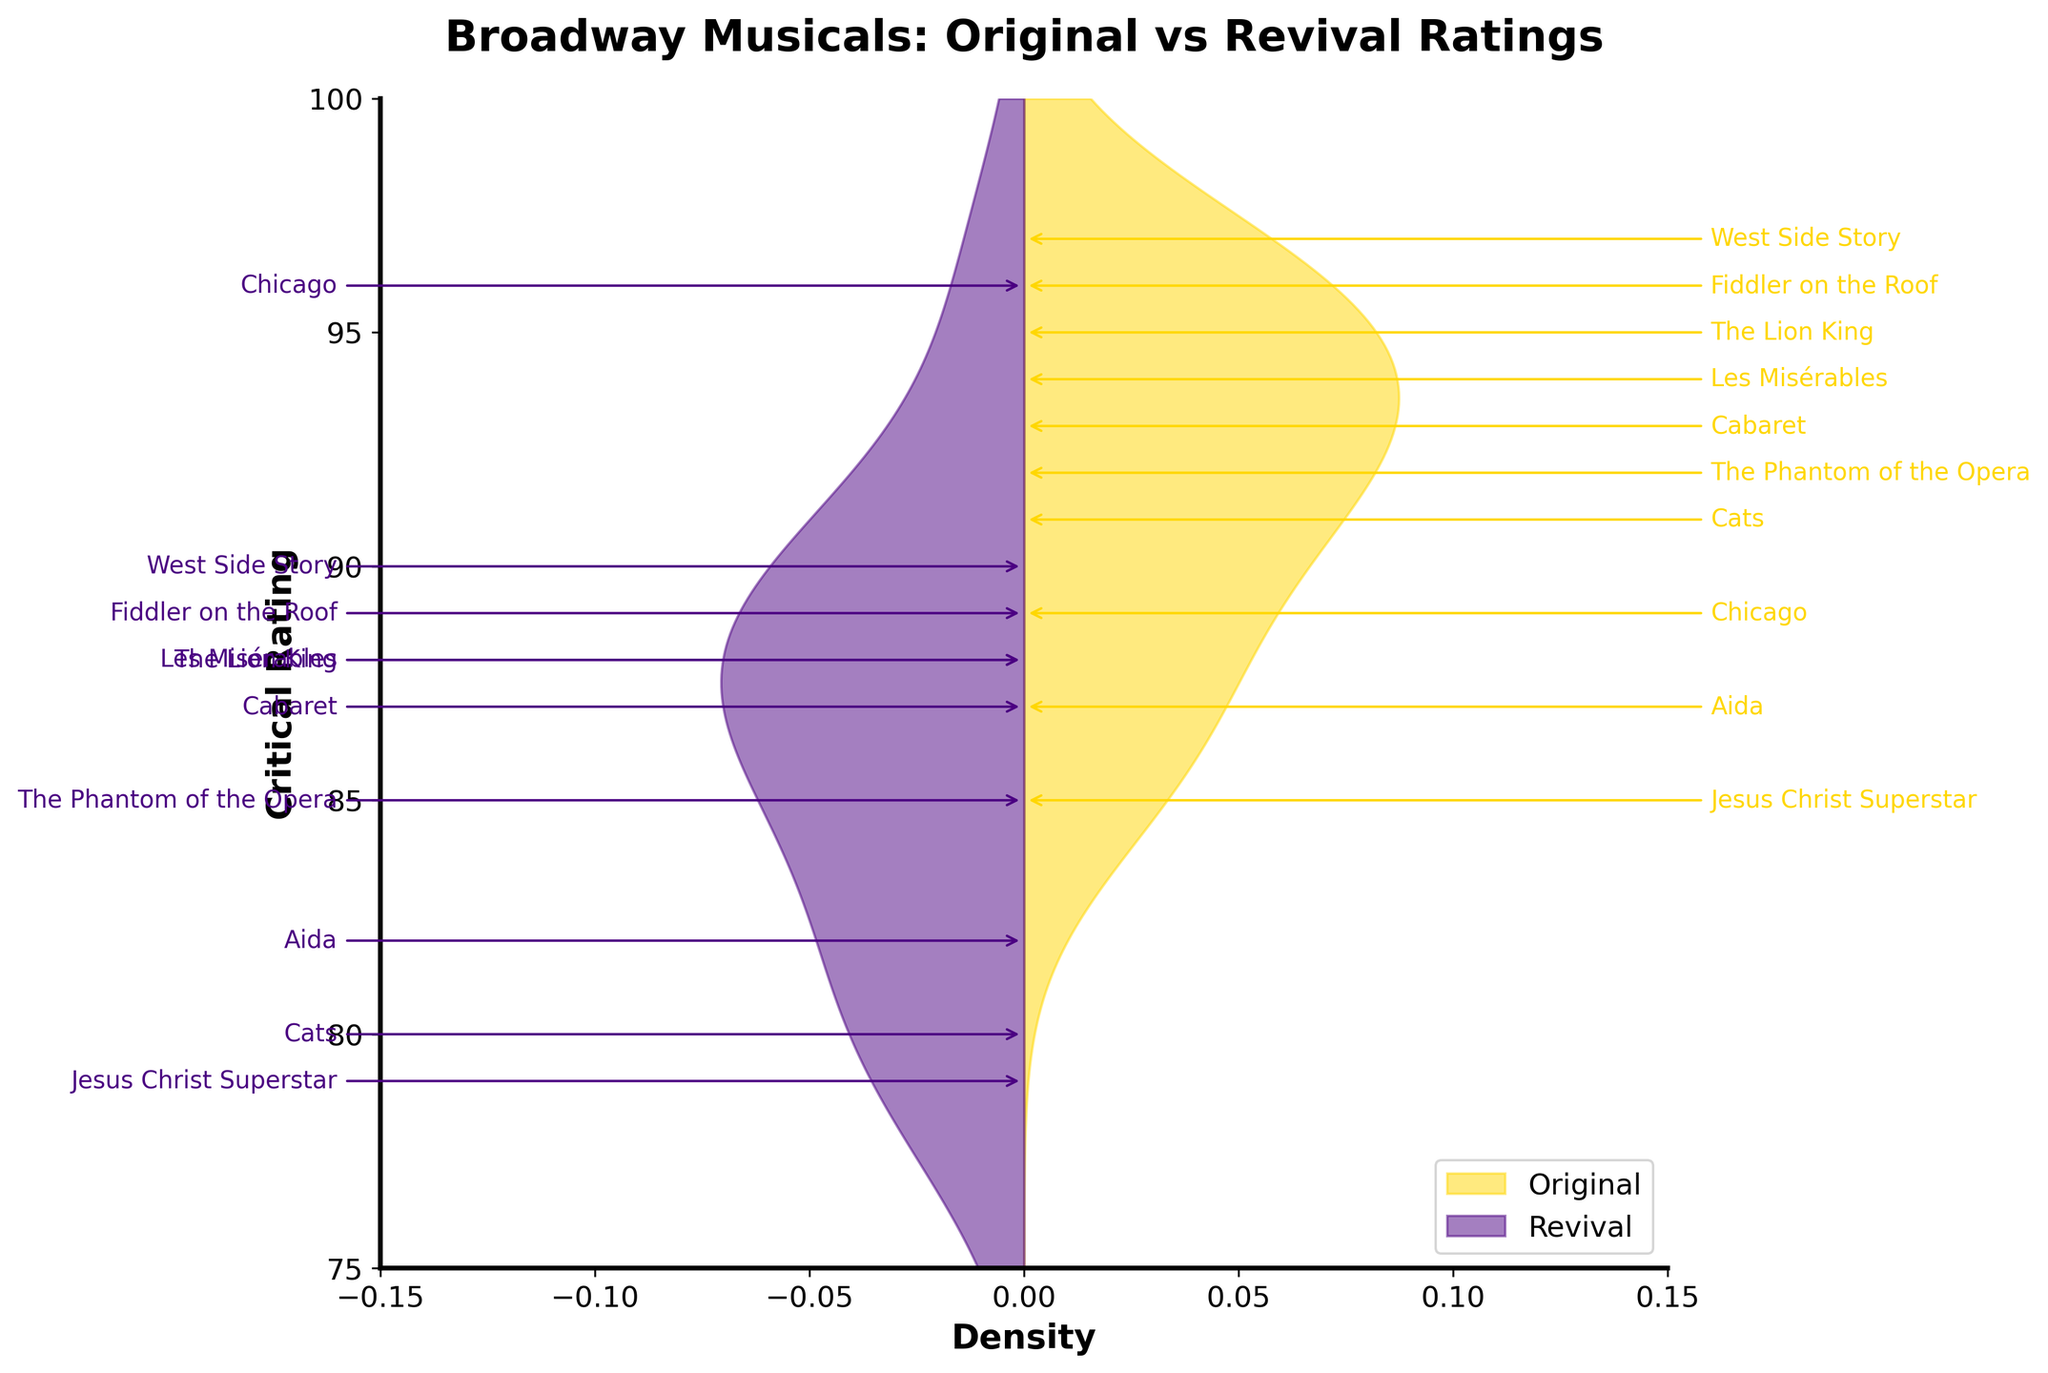what is the title of the plot? The title is located at the top of the plot and is clearly displayed. It provides an overview of the data being visualized. The title is "Broadway Musicals: Original vs Revival Ratings".
Answer: Broadway Musicals: Original vs Revival Ratings what are the colors used to represent original and revival ratings? The colors are indicated in the legend at the bottom right of the plot. Original ratings are in gold color and revival ratings are in indigo color.
Answer: Gold and indigo what is the range of critical ratings shown on the y-axis? The y-axis shows the range of critical ratings, which is clearly labeled on the left side of the plot. The range is from 75 to 100.
Answer: 75 to 100 what is the general trend in critical ratings for original productions compared to revivals? The density plots show the distribution of ratings. The gold area for originals is generally higher towards the upper end of the rating scale while the indigo area for revivals tends to be slightly lower, indicating that original productions generally receive higher ratings.
Answer: Originals generally receive higher ratings which musical shows the greatest improvement in ratings from original to revival? The musical names are annotated at their respective rating points. By comparing the distance between the original and revival ratings of each musical, Chicago has the greatest improvement as its original rating is 89 and revival rating is 96.
Answer: Chicago is there any musical that has a higher revival rating than the original? By checking the annotations and the respective ratings, Chicago is the only musical where revival rating (96) is higher than the original rating (89).
Answer: Chicago which musical has the highest rating in original productions and what is the rating? The annotations and density plot indicate that West Side Story has the highest original rating, which is 97.
Answer: West Side Story with 97 which musical has the lowest revival rating and what is the rating? By examining the annotations for revival ratings, Jesus Christ Superstar has the lowest revival rating, which is 79.
Answer: Jesus Christ Superstar with 79 what is the average rating of original musicals? The original ratings can be summed and divided by the number of original musicals. Calculating the average: (95 + 92 + 89 + 91 + 94 + 87 + 85 + 97 + 93 + 96) / 10 = 91.9
Answer: 91.9 how many musicals are analyzed in the plot? Counting the unique musical names annotated on the plot gives a total of 10 musicals.
Answer: 10 